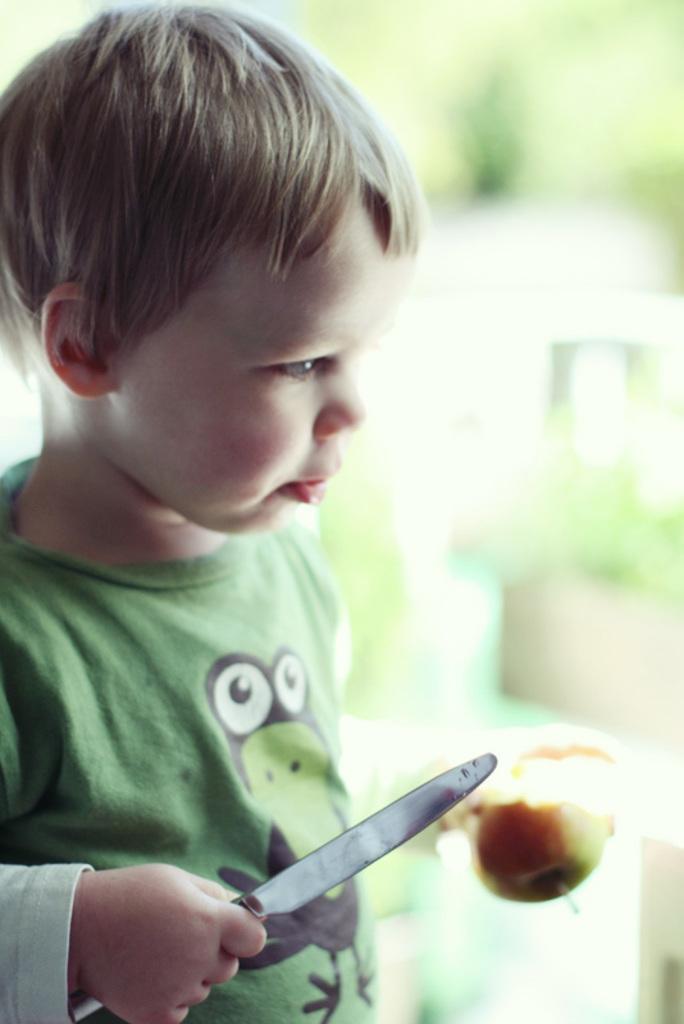Can you describe this image briefly? In this image a boy is holding one knife and a fruit. 